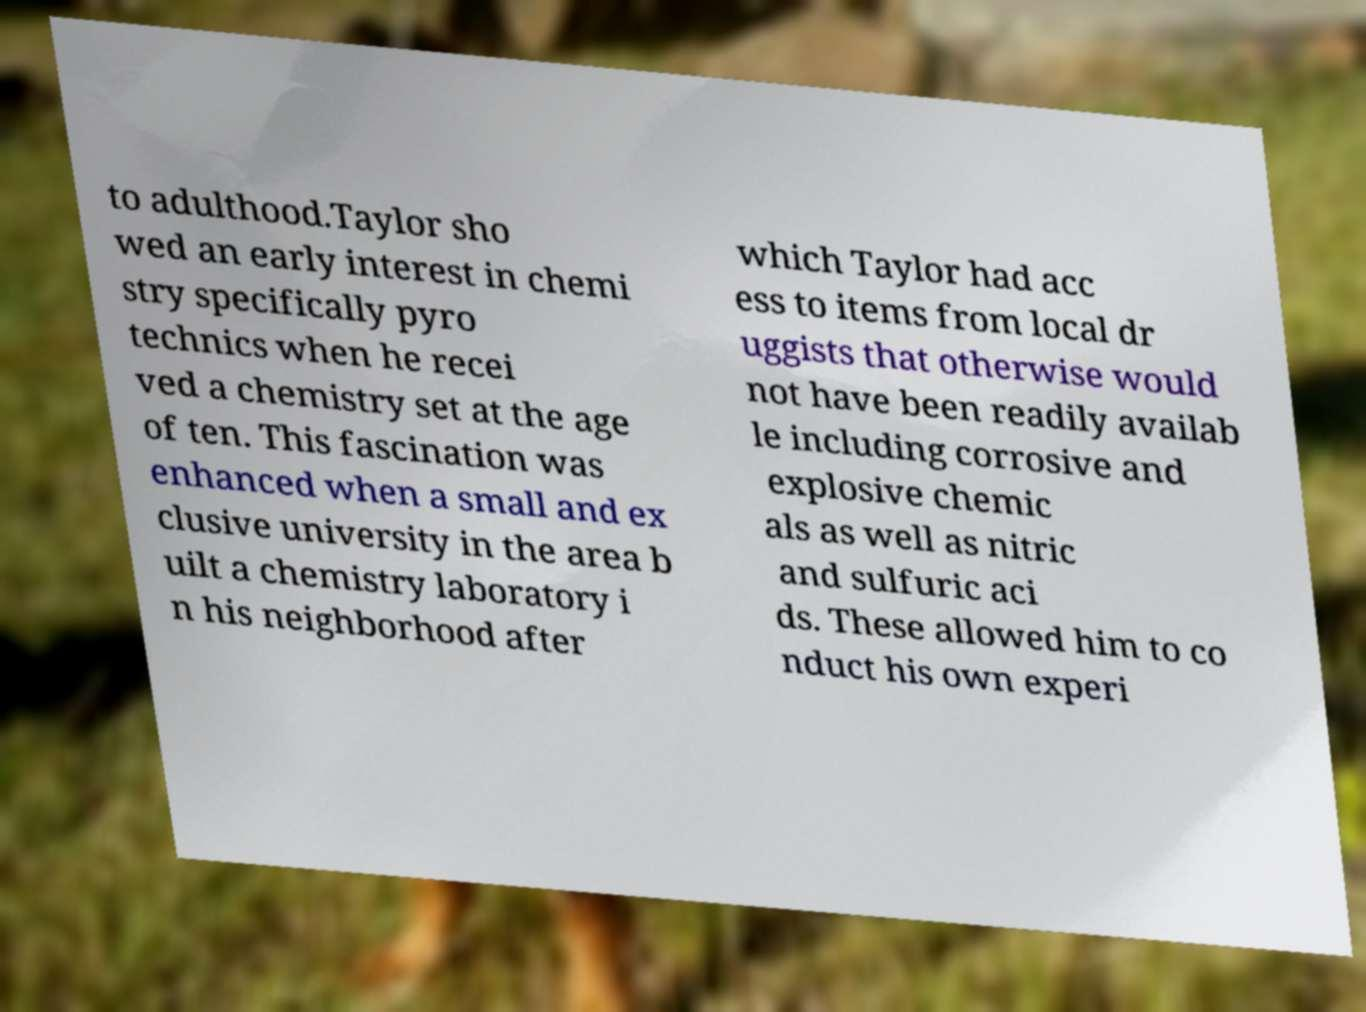There's text embedded in this image that I need extracted. Can you transcribe it verbatim? to adulthood.Taylor sho wed an early interest in chemi stry specifically pyro technics when he recei ved a chemistry set at the age of ten. This fascination was enhanced when a small and ex clusive university in the area b uilt a chemistry laboratory i n his neighborhood after which Taylor had acc ess to items from local dr uggists that otherwise would not have been readily availab le including corrosive and explosive chemic als as well as nitric and sulfuric aci ds. These allowed him to co nduct his own experi 